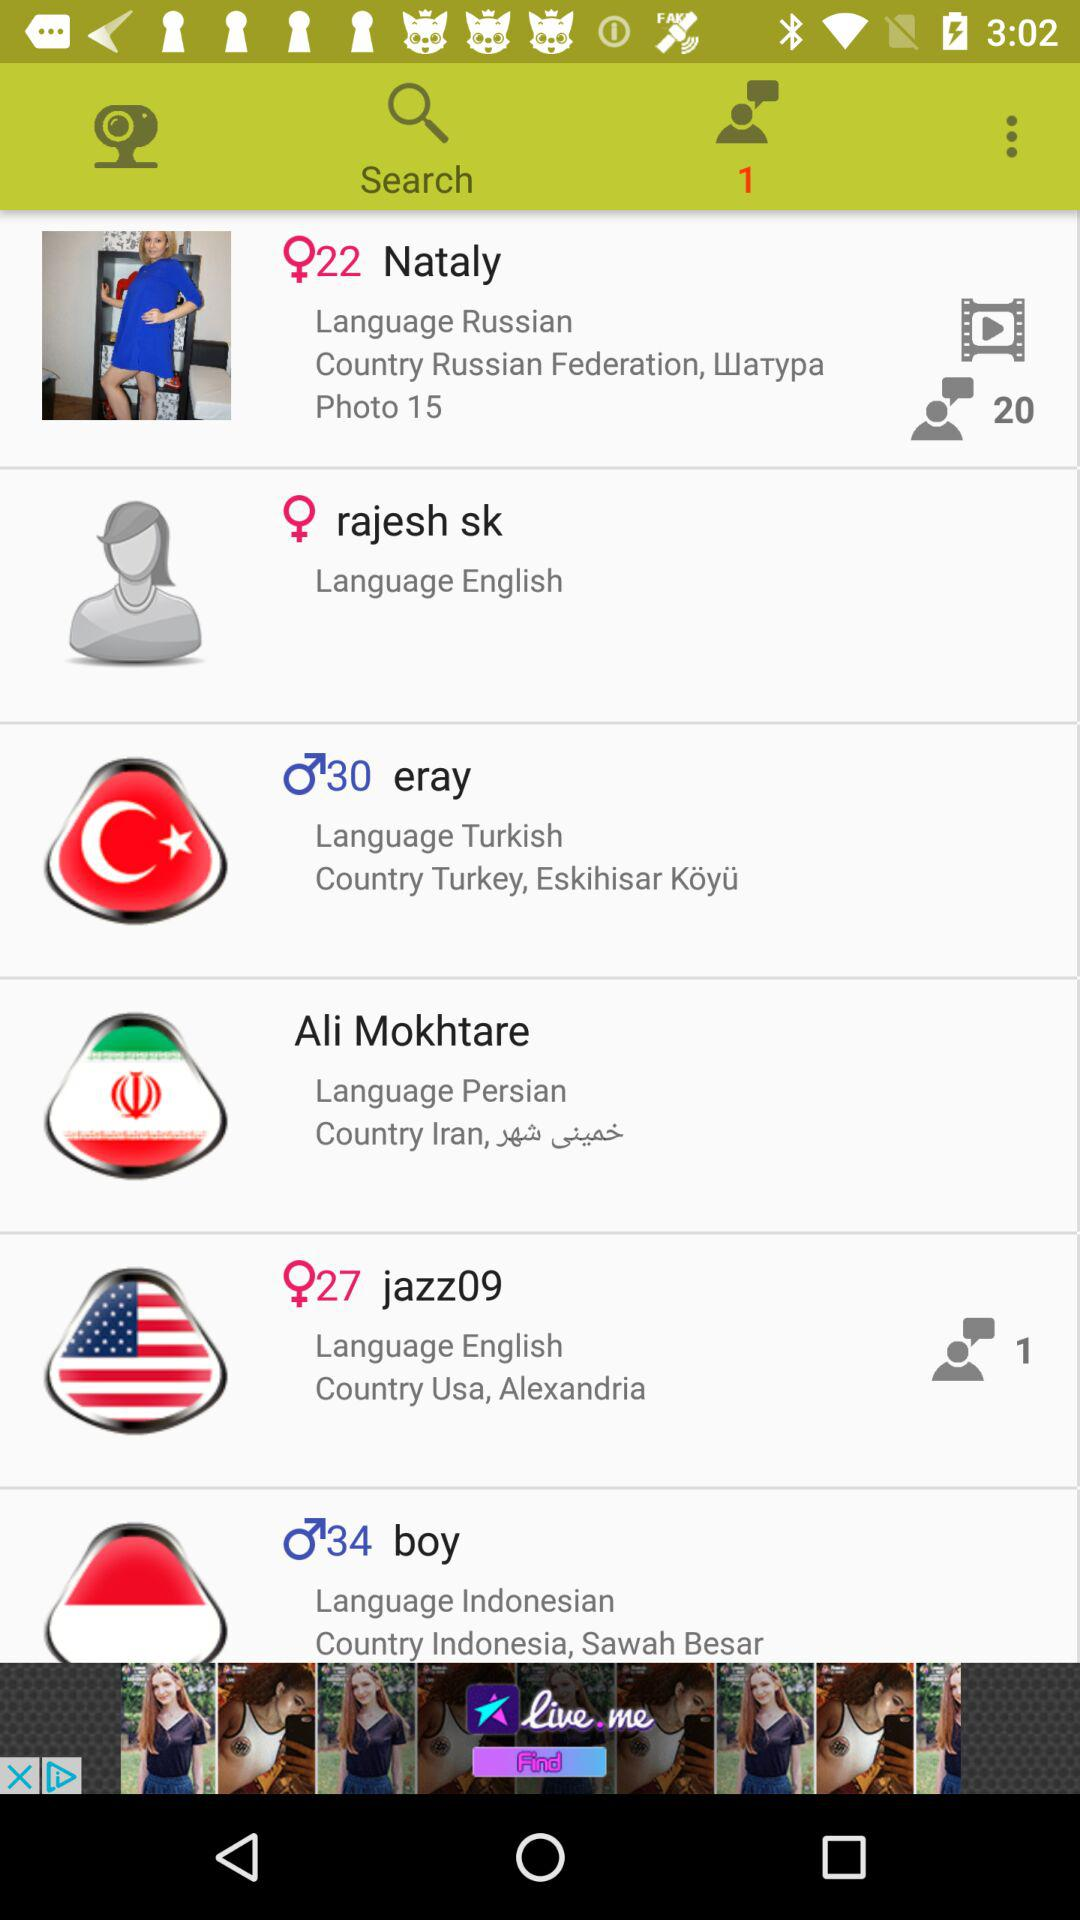Which language is mentioned for the user from Turkey? The language mentioned for the user from Turkey is Turkish. 